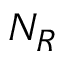<formula> <loc_0><loc_0><loc_500><loc_500>N _ { R }</formula> 